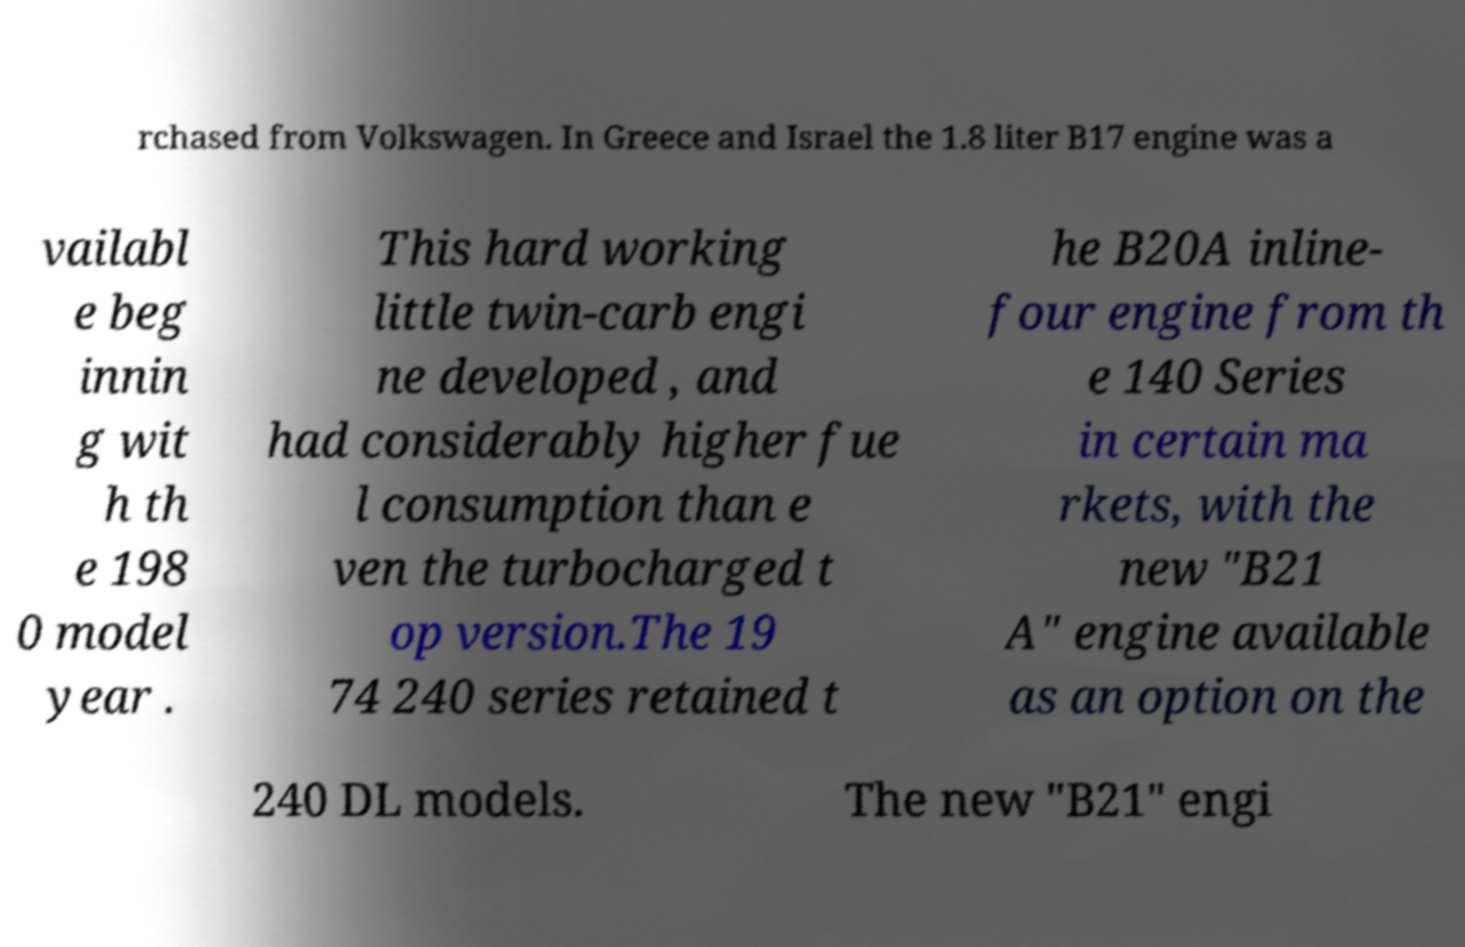Could you extract and type out the text from this image? rchased from Volkswagen. In Greece and Israel the 1.8 liter B17 engine was a vailabl e beg innin g wit h th e 198 0 model year . This hard working little twin-carb engi ne developed , and had considerably higher fue l consumption than e ven the turbocharged t op version.The 19 74 240 series retained t he B20A inline- four engine from th e 140 Series in certain ma rkets, with the new "B21 A" engine available as an option on the 240 DL models. The new "B21" engi 